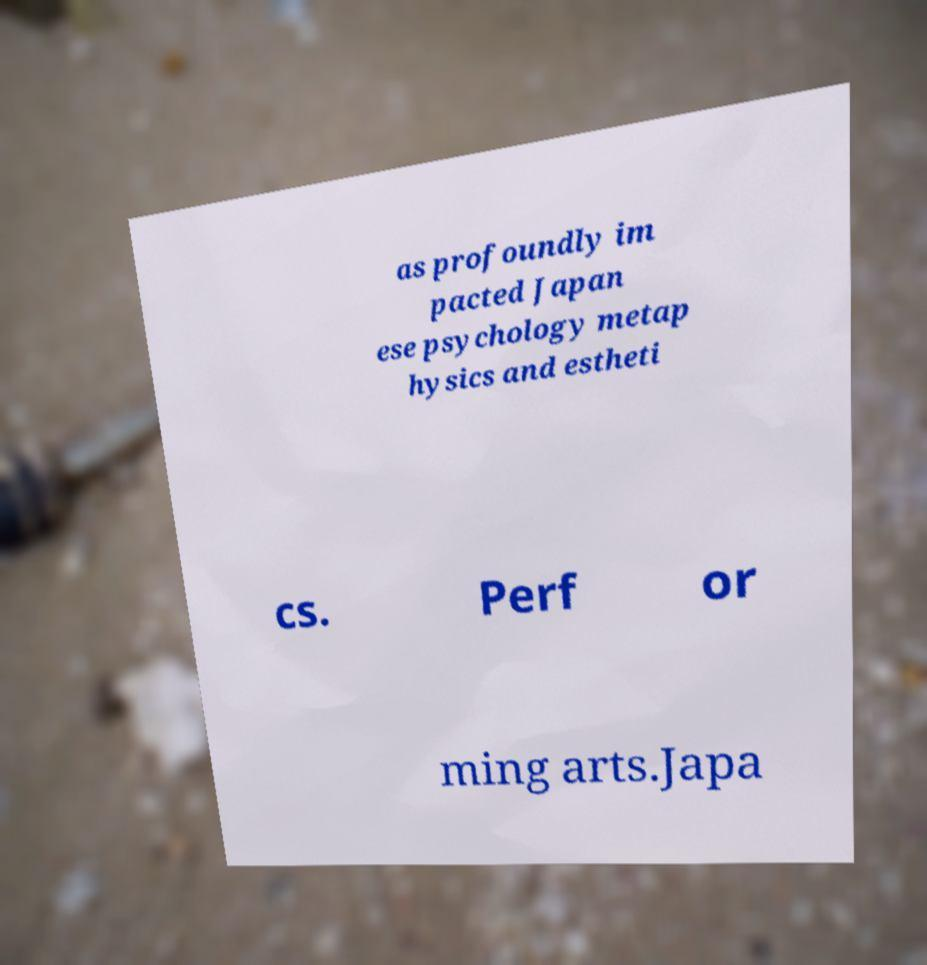Could you extract and type out the text from this image? as profoundly im pacted Japan ese psychology metap hysics and estheti cs. Perf or ming arts.Japa 